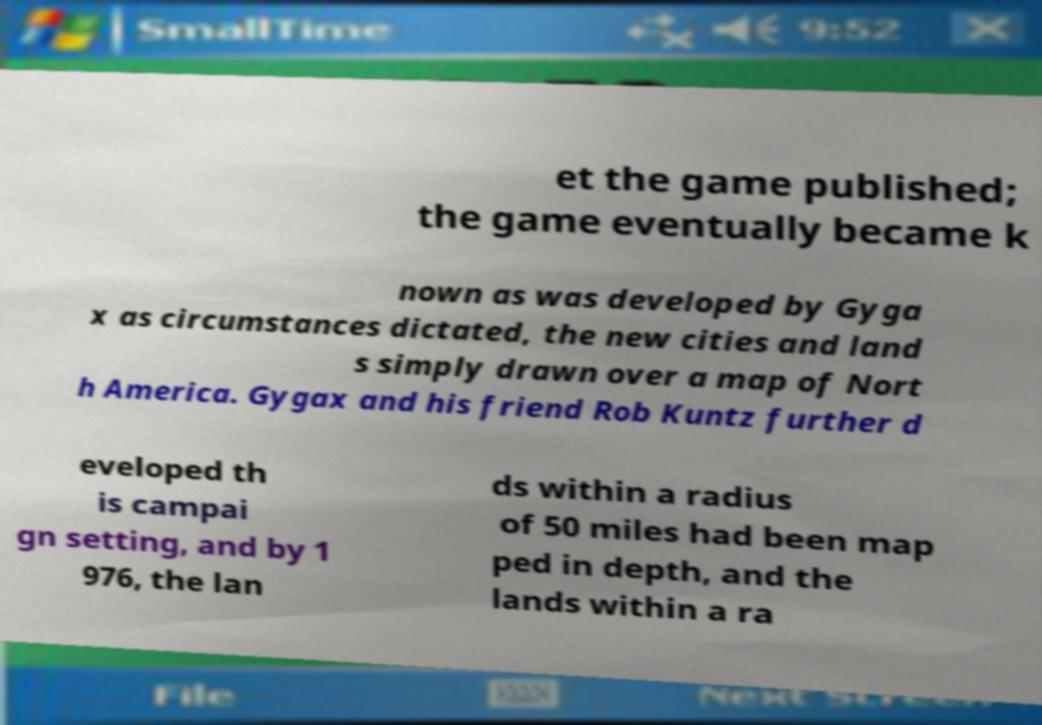Can you accurately transcribe the text from the provided image for me? et the game published; the game eventually became k nown as was developed by Gyga x as circumstances dictated, the new cities and land s simply drawn over a map of Nort h America. Gygax and his friend Rob Kuntz further d eveloped th is campai gn setting, and by 1 976, the lan ds within a radius of 50 miles had been map ped in depth, and the lands within a ra 